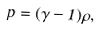<formula> <loc_0><loc_0><loc_500><loc_500>p = ( \gamma - 1 ) \rho ,</formula> 